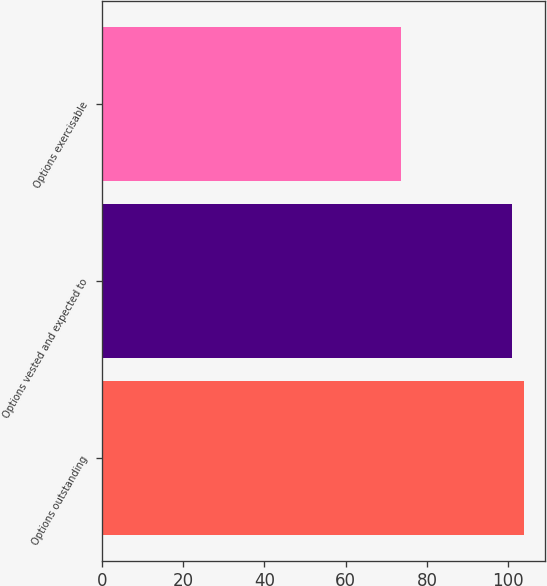Convert chart. <chart><loc_0><loc_0><loc_500><loc_500><bar_chart><fcel>Options outstanding<fcel>Options vested and expected to<fcel>Options exercisable<nl><fcel>103.87<fcel>100.9<fcel>73.6<nl></chart> 